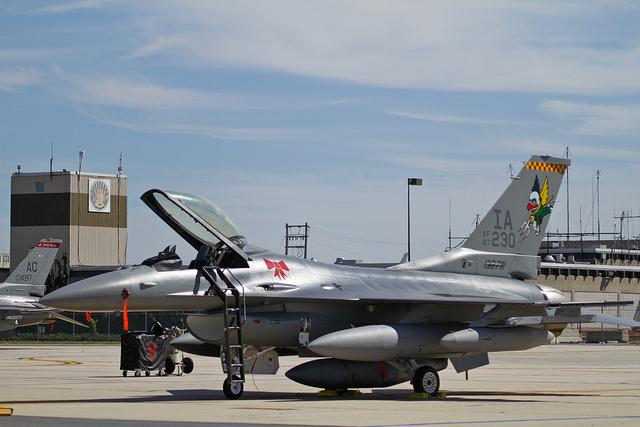What is the sitting capacity of this airplane?
Keep it brief. 1. Are these airliners?
Write a very short answer. No. What is the symbol on the tail of the plane?
Write a very short answer. Bird. Are this cargo planes?
Give a very brief answer. No. What letters are on the tail of the plane?
Give a very brief answer. Ia. What type of aircraft is this?
Quick response, please. Airplane. Is there most likely a pilot in this plane?
Keep it brief. No. When departing from this plane, the passengers will go and pick up what?
Keep it brief. Luggage. What is the plane's logo?
Write a very short answer. Eagle. How does the pilot get to the cockpit?
Write a very short answer. Ladder. What is the narrowest part of the plane?
Give a very brief answer. Nose. 